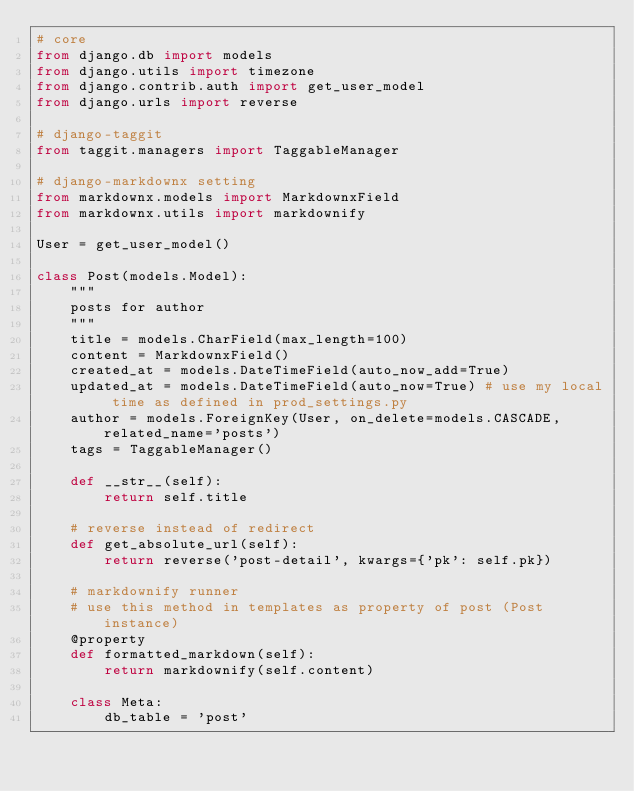Convert code to text. <code><loc_0><loc_0><loc_500><loc_500><_Python_># core
from django.db import models
from django.utils import timezone
from django.contrib.auth import get_user_model
from django.urls import reverse

# django-taggit
from taggit.managers import TaggableManager

# django-markdownx setting
from markdownx.models import MarkdownxField
from markdownx.utils import markdownify

User = get_user_model()

class Post(models.Model):
    """
    posts for author
    """
    title = models.CharField(max_length=100)
    content = MarkdownxField()
    created_at = models.DateTimeField(auto_now_add=True) 
    updated_at = models.DateTimeField(auto_now=True) # use my local time as defined in prod_settings.py
    author = models.ForeignKey(User, on_delete=models.CASCADE, related_name='posts')
    tags = TaggableManager()

    def __str__(self):
        return self.title

    # reverse instead of redirect
    def get_absolute_url(self):
        return reverse('post-detail', kwargs={'pk': self.pk})

    # markdownify runner 
    # use this method in templates as property of post (Post instance)
    @property
    def formatted_markdown(self):
        return markdownify(self.content)

    class Meta:
        db_table = 'post'</code> 